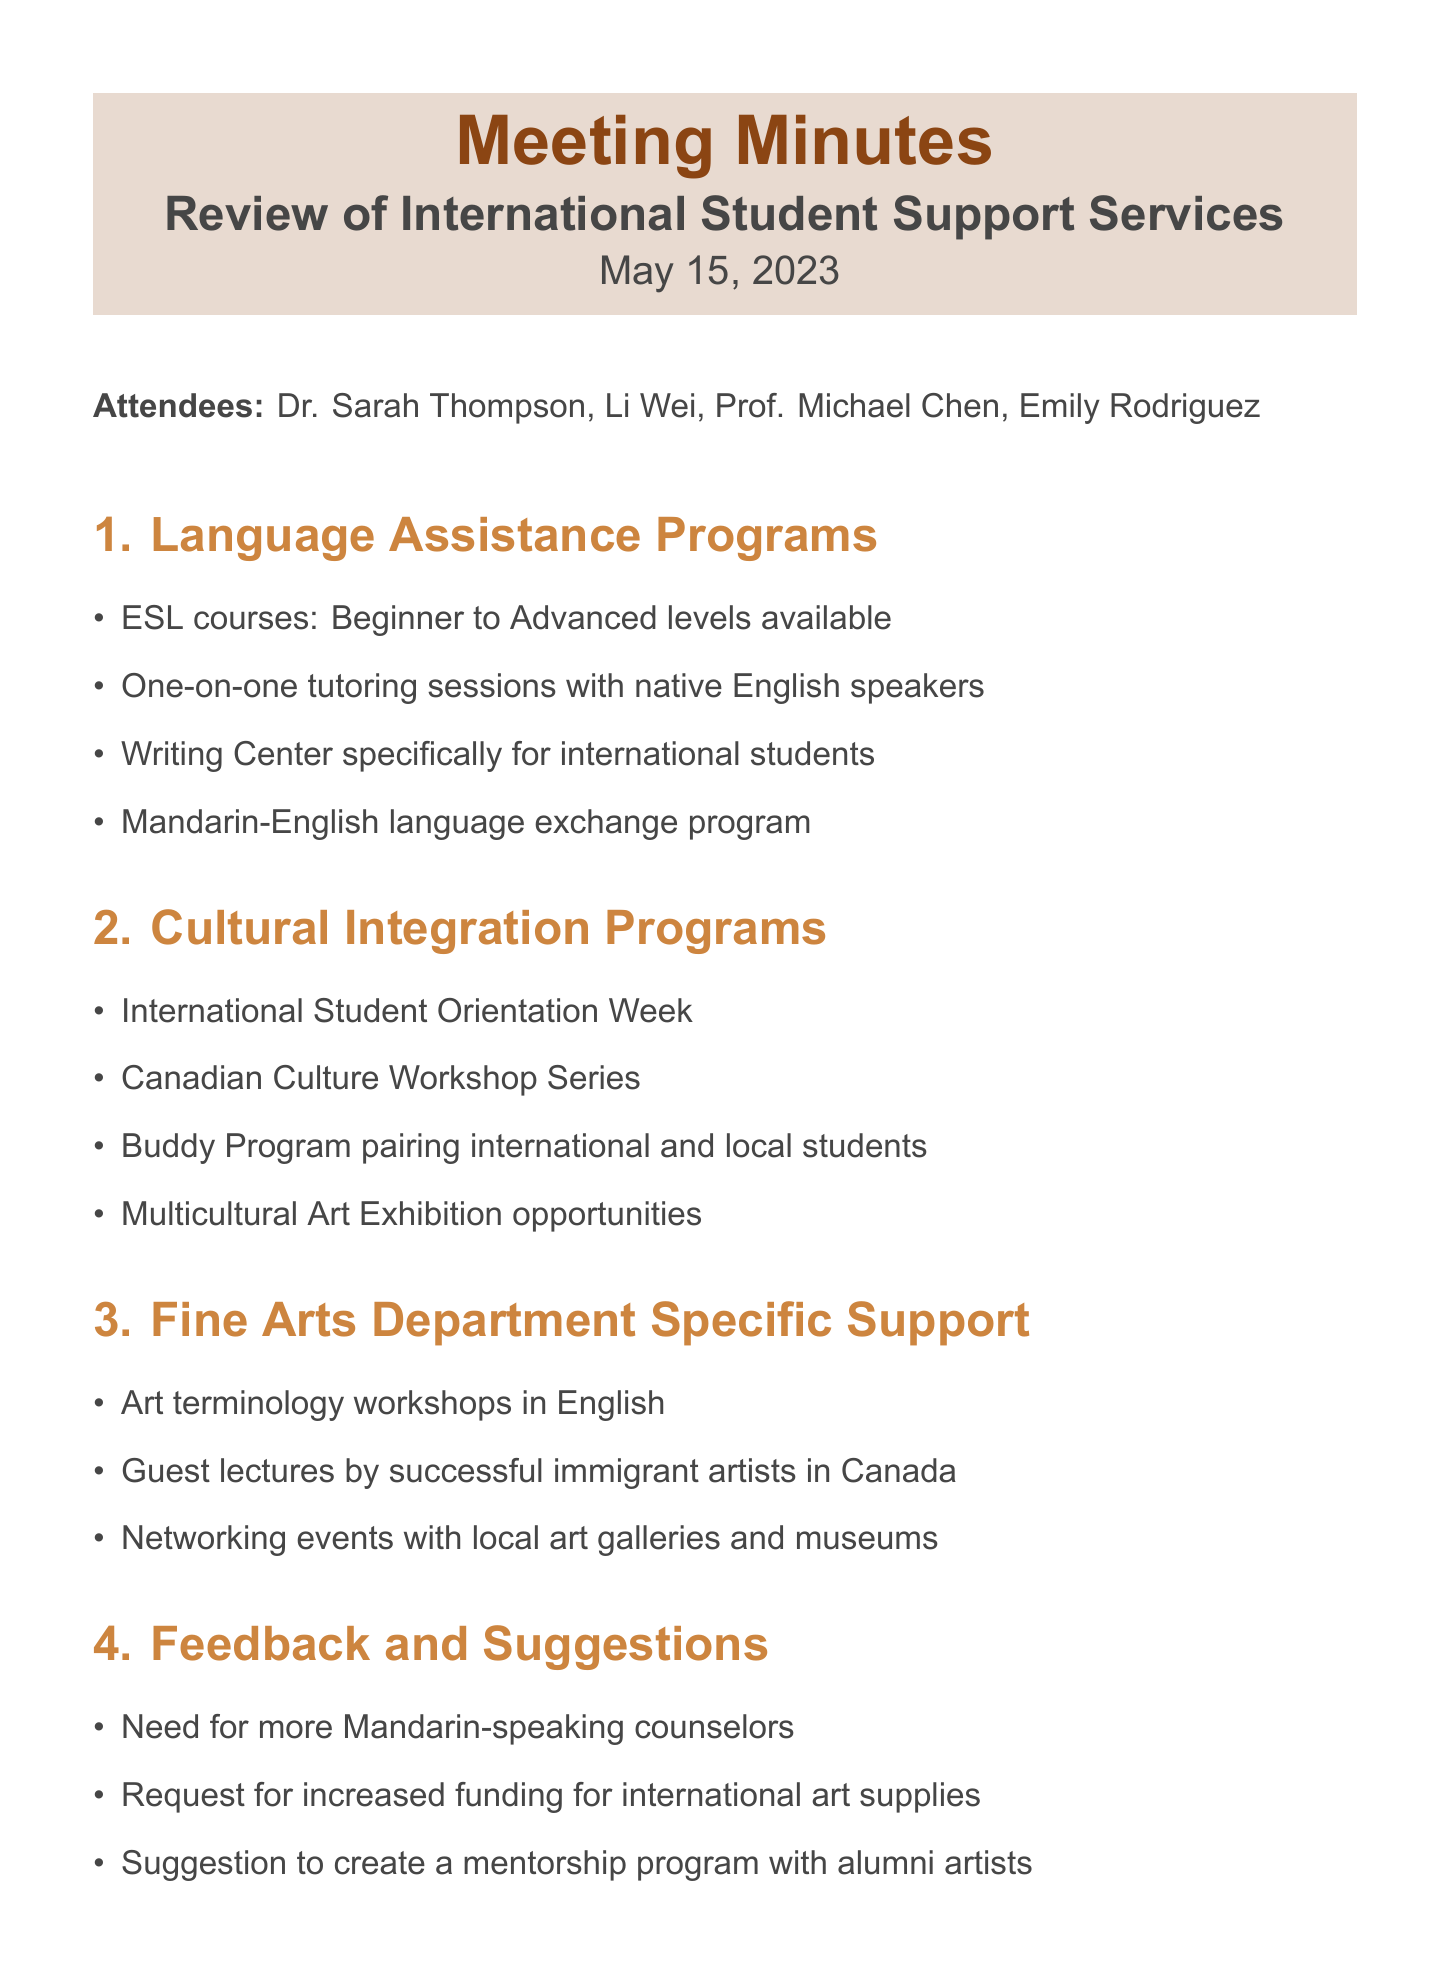What is the date of the meeting? The date of the meeting is explicitly stated in the document.
Answer: May 15, 2023 Who is the ESL Program Coordinator? The document lists attendees, including the ESL Program Coordinator.
Answer: Emily Rodriguez What type of workshop is mentioned for cultural integration? The document lists specific cultural integration programs, including workshops.
Answer: Canadian Culture Workshop Series How many action items are listed in the document? The document contains a section listing action items, which can be counted.
Answer: Three What specific support does the Fine Arts Department offer for terminology? The document details specific support services available for the Fine Arts Department.
Answer: Art terminology workshops in English What suggestion was made concerning Mandarin-speaking counselors? The document includes feedback and suggestions, specifically mentioning a need.
Answer: Need for more Mandarin-speaking counselors What is the focus of the planned 'Art English' course? The document provides information about an action item related to language assistance.
Answer: Art English What is scheduled for the next meeting date? The document has a section stating the next meeting date.
Answer: September 1, 2023 